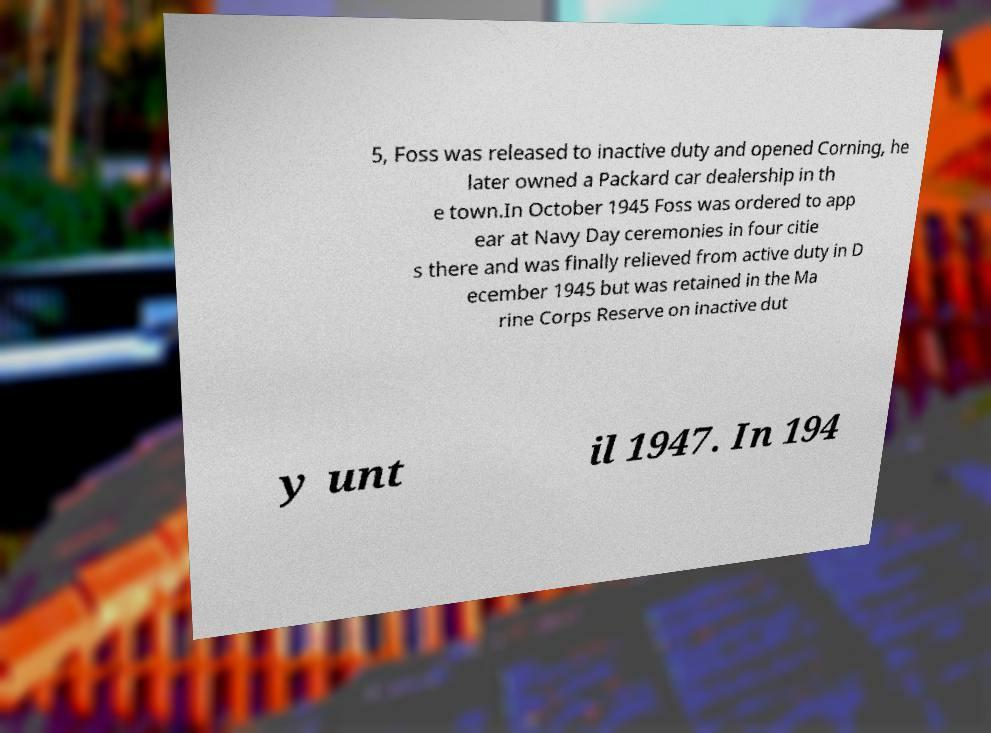There's text embedded in this image that I need extracted. Can you transcribe it verbatim? 5, Foss was released to inactive duty and opened Corning, he later owned a Packard car dealership in th e town.In October 1945 Foss was ordered to app ear at Navy Day ceremonies in four citie s there and was finally relieved from active duty in D ecember 1945 but was retained in the Ma rine Corps Reserve on inactive dut y unt il 1947. In 194 